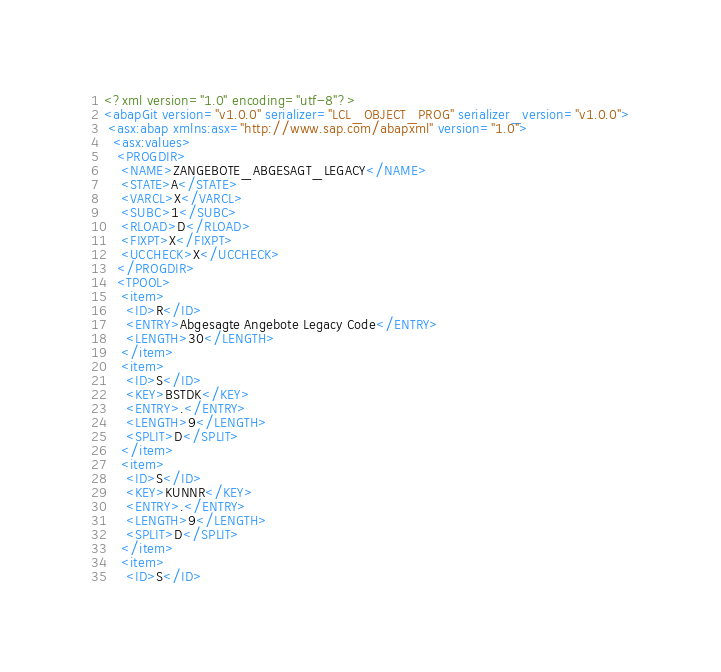Convert code to text. <code><loc_0><loc_0><loc_500><loc_500><_XML_><?xml version="1.0" encoding="utf-8"?>
<abapGit version="v1.0.0" serializer="LCL_OBJECT_PROG" serializer_version="v1.0.0">
 <asx:abap xmlns:asx="http://www.sap.com/abapxml" version="1.0">
  <asx:values>
   <PROGDIR>
    <NAME>ZANGEBOTE_ABGESAGT_LEGACY</NAME>
    <STATE>A</STATE>
    <VARCL>X</VARCL>
    <SUBC>1</SUBC>
    <RLOAD>D</RLOAD>
    <FIXPT>X</FIXPT>
    <UCCHECK>X</UCCHECK>
   </PROGDIR>
   <TPOOL>
    <item>
     <ID>R</ID>
     <ENTRY>Abgesagte Angebote Legacy Code</ENTRY>
     <LENGTH>30</LENGTH>
    </item>
    <item>
     <ID>S</ID>
     <KEY>BSTDK</KEY>
     <ENTRY>.</ENTRY>
     <LENGTH>9</LENGTH>
     <SPLIT>D</SPLIT>
    </item>
    <item>
     <ID>S</ID>
     <KEY>KUNNR</KEY>
     <ENTRY>.</ENTRY>
     <LENGTH>9</LENGTH>
     <SPLIT>D</SPLIT>
    </item>
    <item>
     <ID>S</ID></code> 